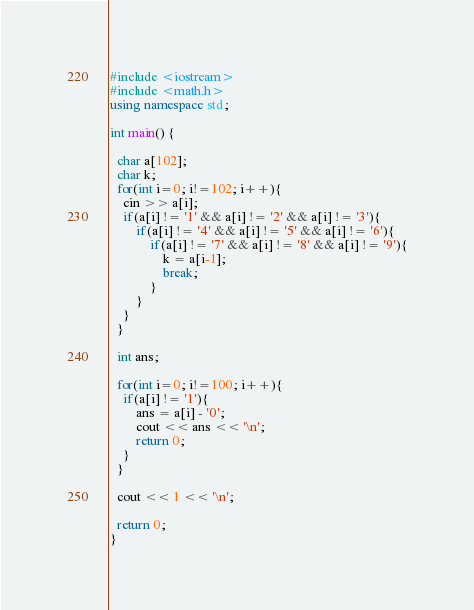Convert code to text. <code><loc_0><loc_0><loc_500><loc_500><_C++_>#include <iostream>
#include <math.h>
using namespace std;

int main() {
  
  char a[102];
  char k;
  for(int i=0; i!=102; i++){
  	cin >> a[i];
  	if(a[i] != '1' && a[i] != '2' && a[i] != '3'){
  		if(a[i] != '4' && a[i] != '5' && a[i] != '6'){
  			if(a[i] != '7' && a[i] != '8' && a[i] != '9'){
  				k = a[i-1];
  				break;
  			}
  		}
  	}
  }

  int ans;

  for(int i=0; i!=100; i++){
  	if(a[i] != '1'){
  		ans = a[i] - '0';
  		cout << ans << '\n';
  		return 0;
  	}
  }

  cout << 1 << '\n';

  return 0;
}


</code> 